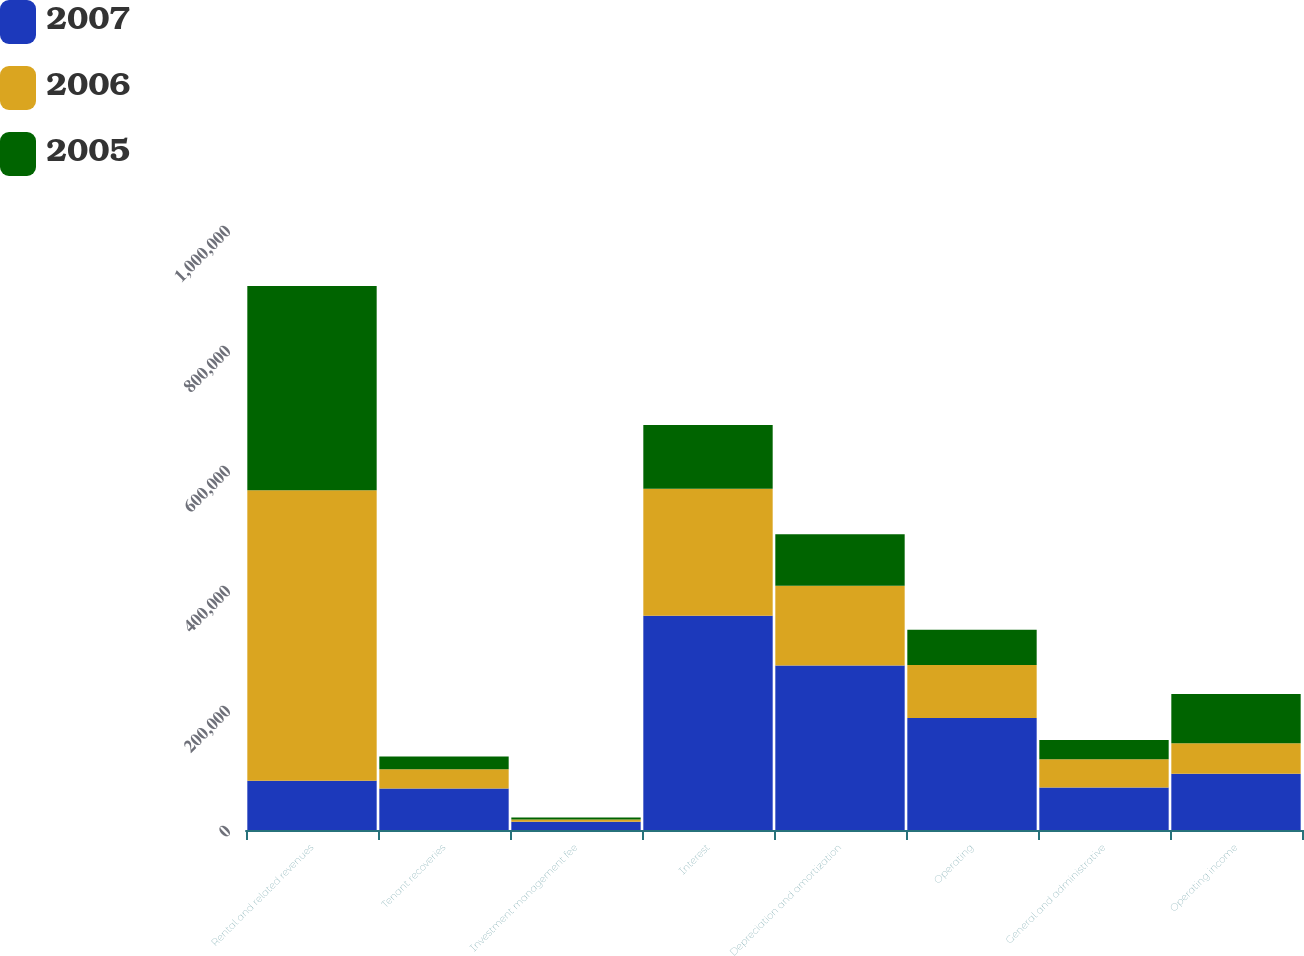Convert chart. <chart><loc_0><loc_0><loc_500><loc_500><stacked_bar_chart><ecel><fcel>Rental and related revenues<fcel>Tenant recoveries<fcel>Investment management fee<fcel>Interest<fcel>Depreciation and amortization<fcel>Operating<fcel>General and administrative<fcel>Operating income<nl><fcel>2007<fcel>82186<fcel>69354<fcel>13581<fcel>357024<fcel>274348<fcel>186550<fcel>70930<fcel>93657<nl><fcel>2006<fcel>483921<fcel>32067<fcel>3895<fcel>211869<fcel>132916<fcel>88521<fcel>47195<fcel>50813<nl><fcel>2005<fcel>340484<fcel>21067<fcel>3184<fcel>106224<fcel>85781<fcel>58710<fcel>31834<fcel>82186<nl></chart> 